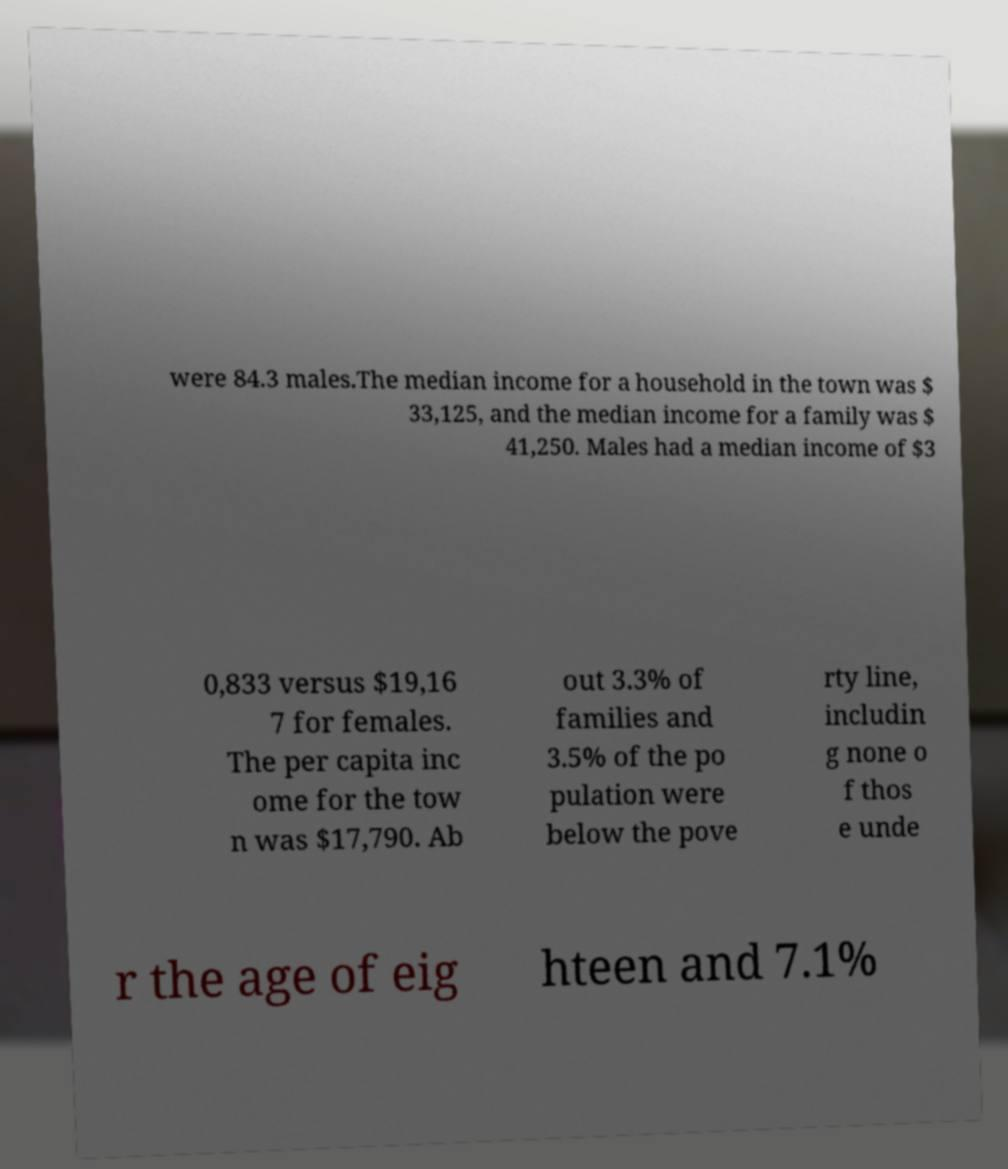Could you extract and type out the text from this image? were 84.3 males.The median income for a household in the town was $ 33,125, and the median income for a family was $ 41,250. Males had a median income of $3 0,833 versus $19,16 7 for females. The per capita inc ome for the tow n was $17,790. Ab out 3.3% of families and 3.5% of the po pulation were below the pove rty line, includin g none o f thos e unde r the age of eig hteen and 7.1% 